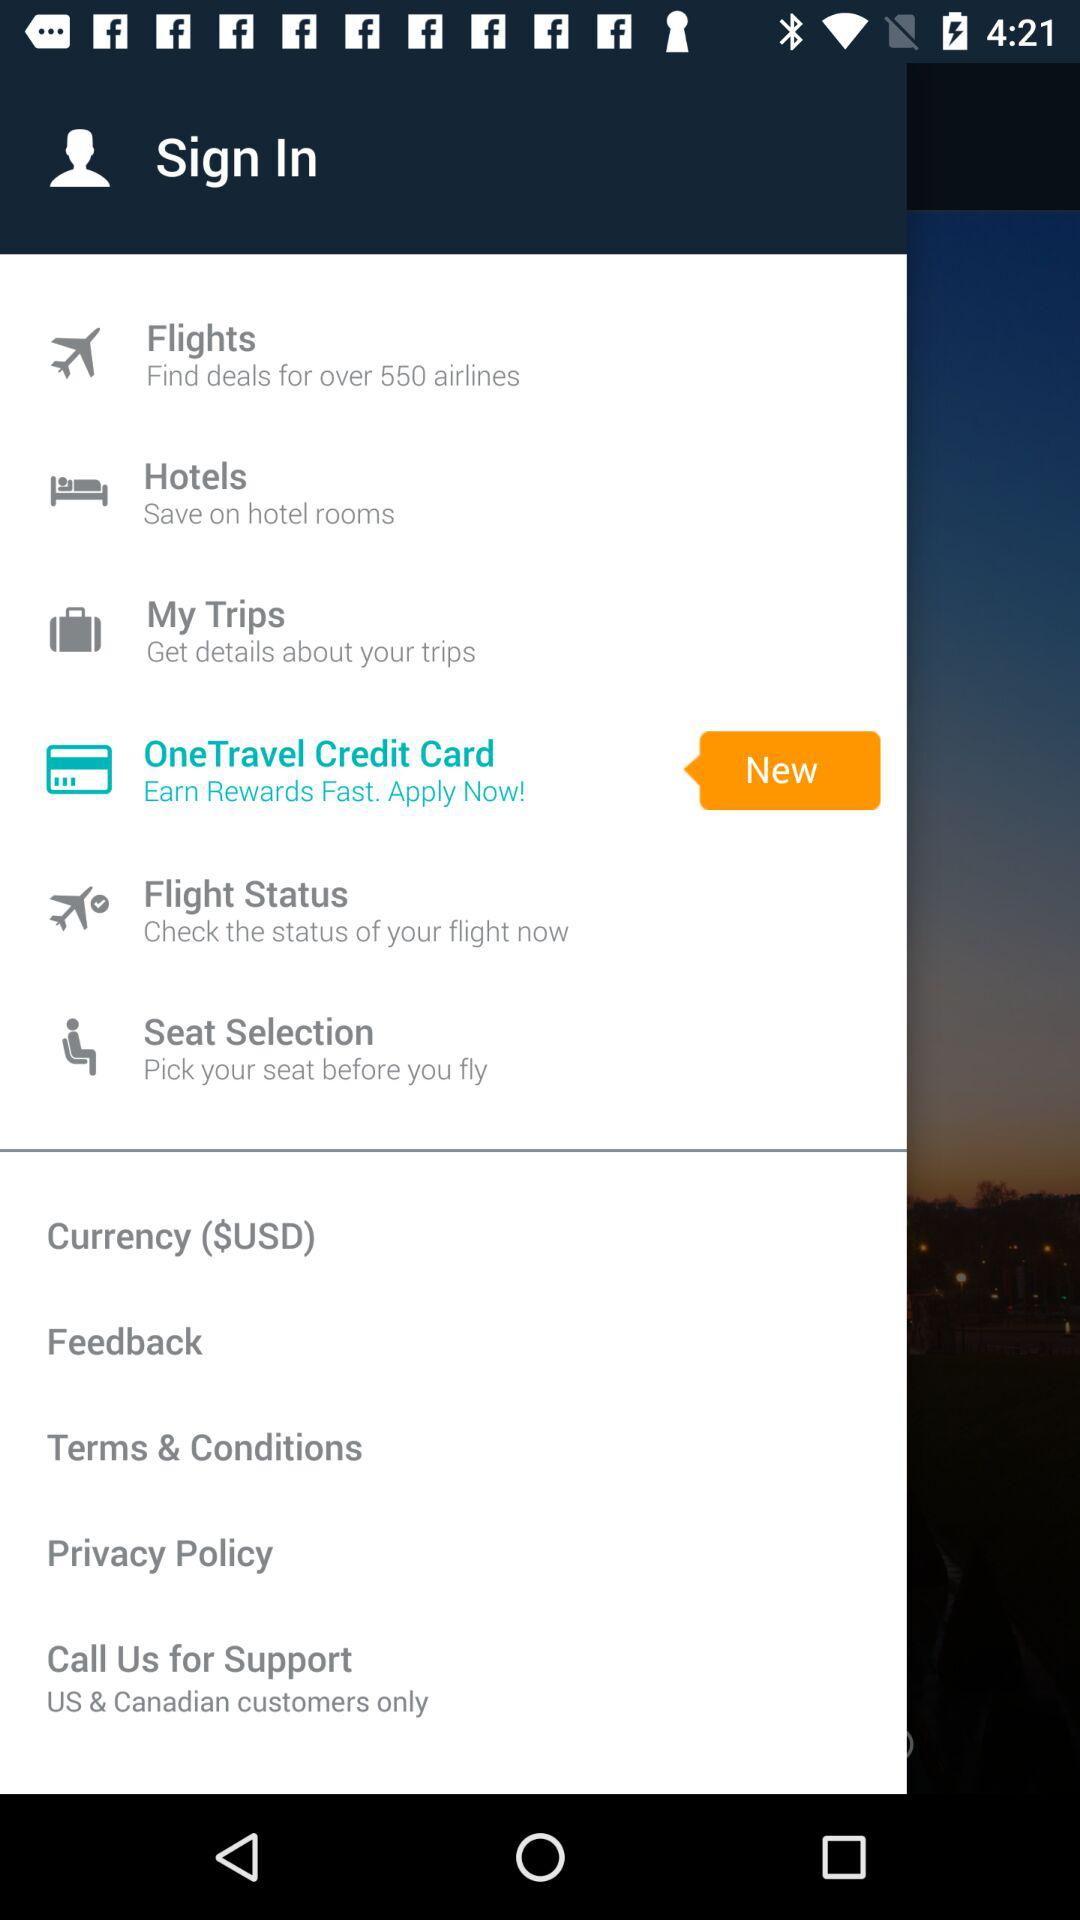What's the currency? The currency is "$USD". 